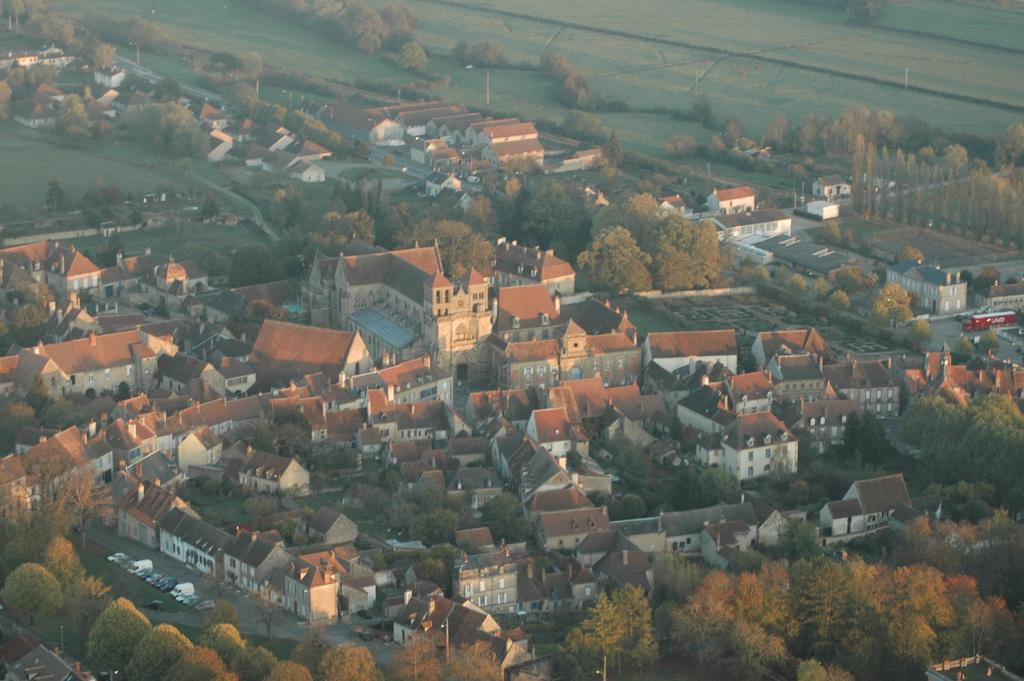Where was the image captured? The image was captured far away from the city. What can be seen within the city in the image? There are trees and houses in the city. What is visible on the outskirts of the city in the image? There is beautiful greenery on the city outskirts. How many eyes can be seen on the crow in the image? There is no crow present in the image. What type of plantation is visible in the image? There is no plantation visible in the image. 